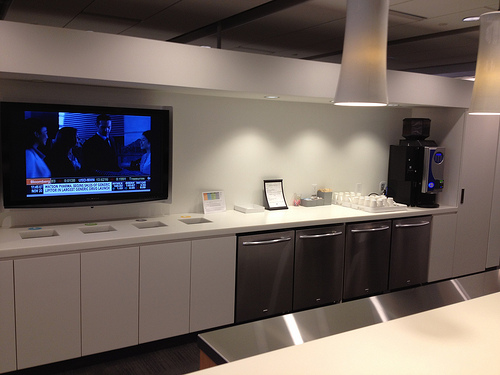Describe the overall ambiance of the room. The room has a modern, clean, and professional ambiance. The combination of stainless steel appliances, white cabinets, and minimalist decor creates a sleek and inviting environment. What can be inferred about the use of this room? The room appears to be a break room or kitchenette area in a professional setting, such as an office. The presence of a coffee dispenser and appliances suggests it is used for preparing and consuming meals and beverages. The television and comfortable setup indicate it might be a place where staff can relax and unwind during breaks. Create a story involving the people who might use this room. Every morning, the employees of the innovative tech startup gather in this room for their coffee fix. Sarah, the marketing specialist, usually starts her day with a cup of black coffee while catching up on the morning news on the television. John's a software developer with a liking for herbal tea, which he prepares using the coffee dispenser. The room becomes a hub of light-hearted conversation, brainstorming sessions, and occasional celebrations over milestones achieved. They've even hosted informal meetings around the countertop, making it a central piece of their daily routine and bonding experience, fostering a sense of community and teamwork within the company. 